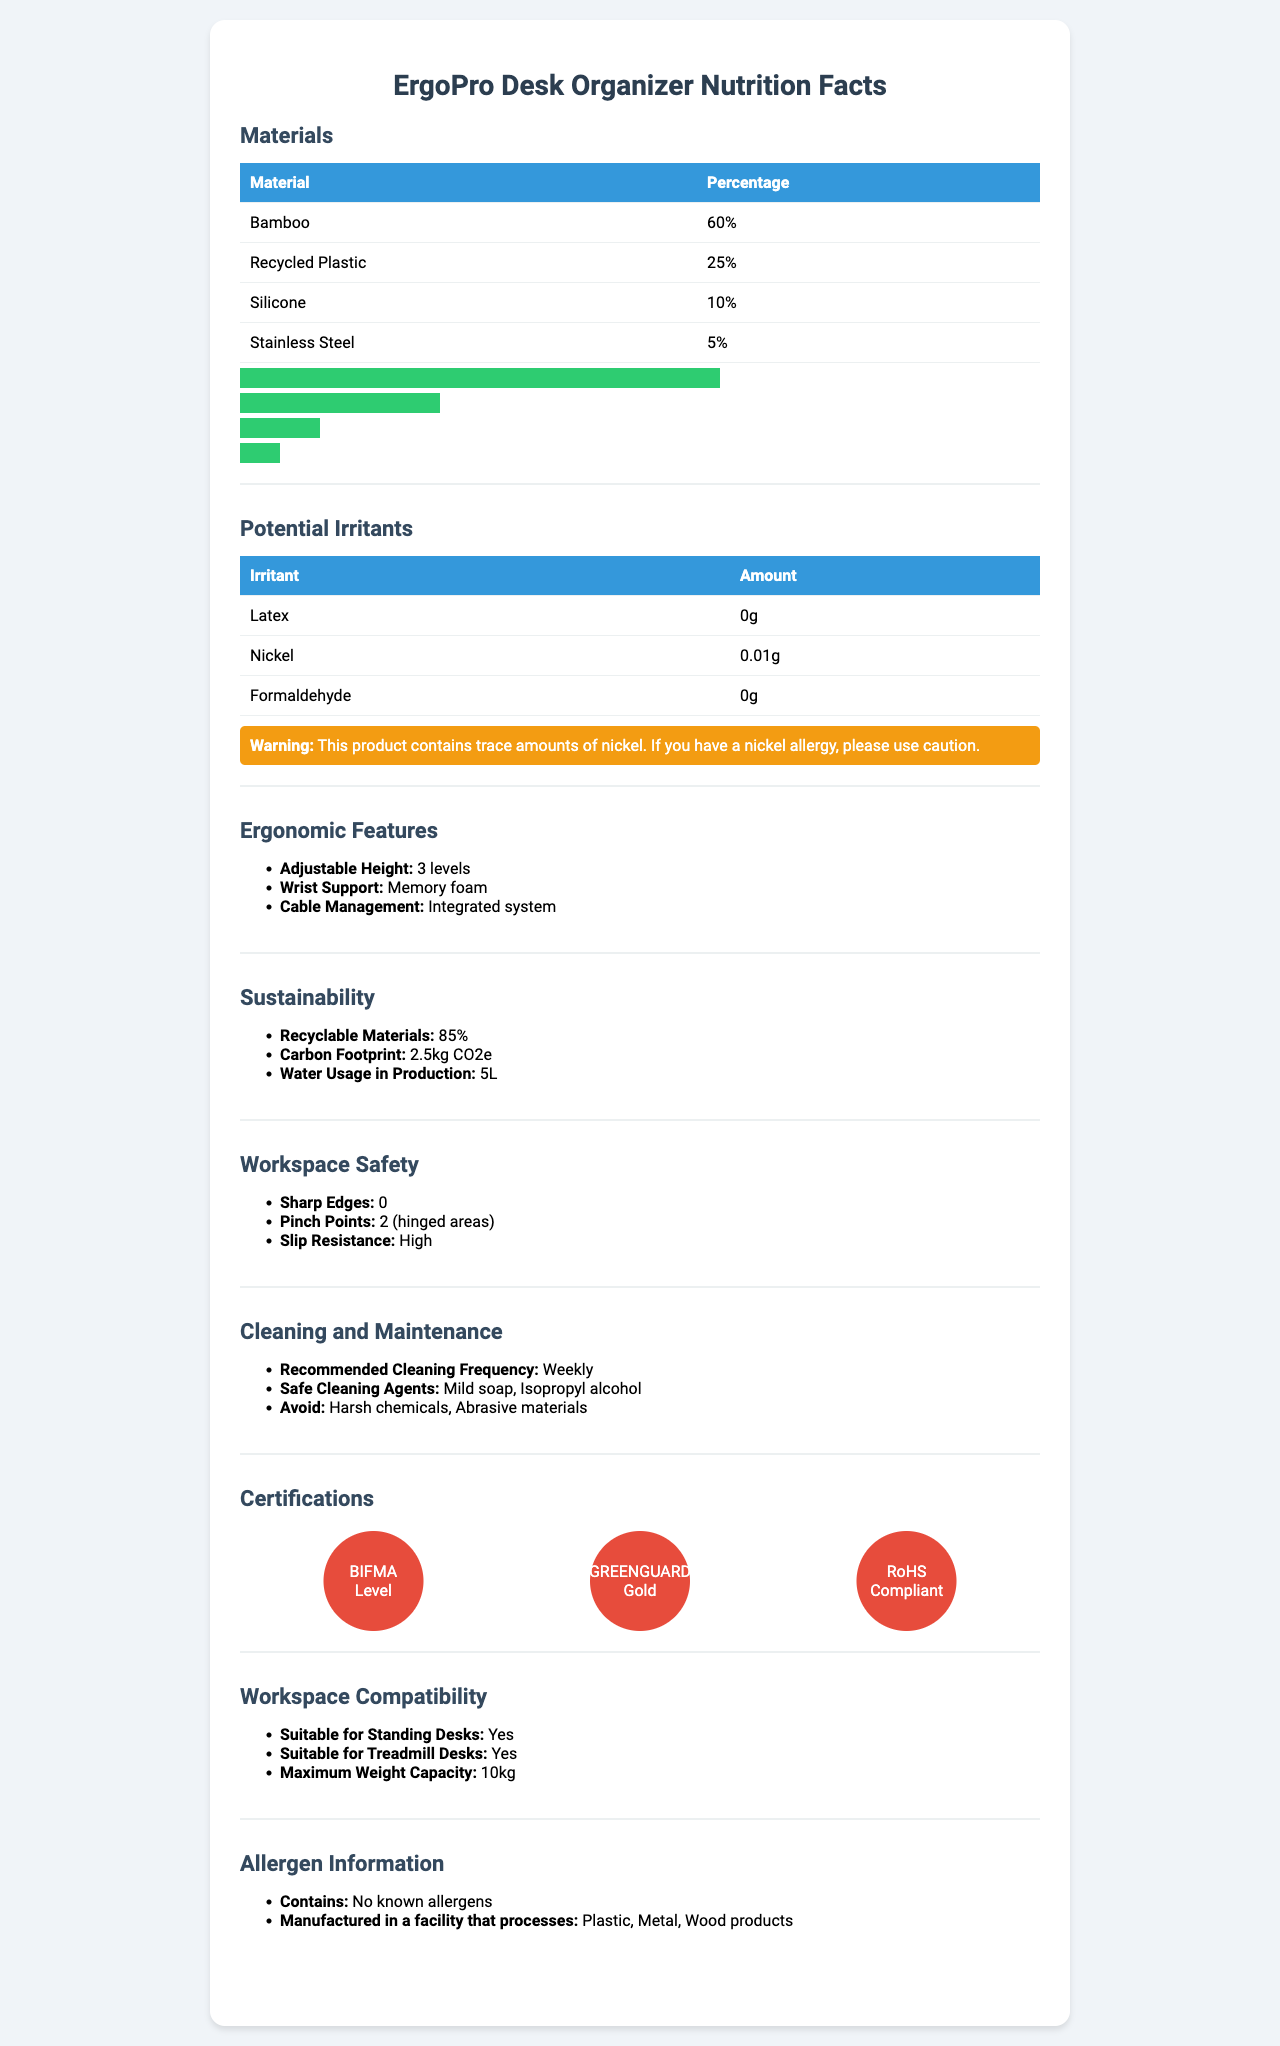what is the name of the product? The name of the product is given at the top of the document as "ErgoPro Desk Organizer".
Answer: ErgoPro Desk Organizer what percentage of the product is made from recycled plastic? The percentage of recycled plastic is listed under the "Materials" section as 25%.
Answer: 25% how many pinch points does the product have? The "Workspace Safety" section lists that the product has 2 pinch points in hinged areas.
Answer: 2 what is recommended cleaning frequency for the product? The "Cleaning and Maintenance" section recommends cleaning the product on a weekly basis.
Answer: Weekly does the product contain any known allergens? The "Allergen Information" section states that the product contains no known allergens.
Answer: No what is the warning regarding potential irritants? A. Contains Nickel, use caution if allergic B. Contains Latex, avoid if allergic C. Contains Formaldehyde, avoid if sensitive D. Contains BPA, use caution The "Potential Irritants" section has a warning that states the product contains trace amounts of nickel and advises caution for those with a nickel allergy.
Answer: A. Contains Nickel, use caution if allergic what is the maximum weight capacity of the product? A. 5kg B. 8kg C. 10kg D. 15kg The "Workspace Compatibility" section lists the maximum weight capacity of the product as 10kg.
Answer: C. 10kg are harsh chemicals recommended for cleaning the product? (True/False) The "Cleaning and Maintenance" section advises avoiding harsh chemicals when cleaning the product.
Answer: False summarize the main features of the ErgoPro Desk Organizer The product is described as a sustainable and ergonomic desk organizer made from eco-friendly materials, with potential allergen alerts and cleaning recommendations for maintaining its safety and usability.
Answer: The ErgoPro Desk Organizer is made primarily from bamboo and recycled plastic, with ergonomic features like adjustable height and wrist support. It contains no known allergens but does have trace amounts of nickel. It is sustainable with recyclable materials and has key safety features like high slip resistance. It requires weekly cleaning with mild soap or isopropyl alcohol. what is the production water usage for this product? The "Sustainability" section specifies that 5L of water is used in production.
Answer: 5L which certification indicates the product meets ergonomic standards? The document lists several certifications like BIFMA Level and GREENGUARD Gold, but does not specify which one directly relates to ergonomic standards.
Answer: Not enough information is the product slip resistant? The "Workspace Safety" section states that the slip resistance of the product is high.
Answer: Yes how many levels of adjustable height does the product have? The "Ergonomic Features" section lists that the product has an adjustable height with 3 levels.
Answer: 3 levels 